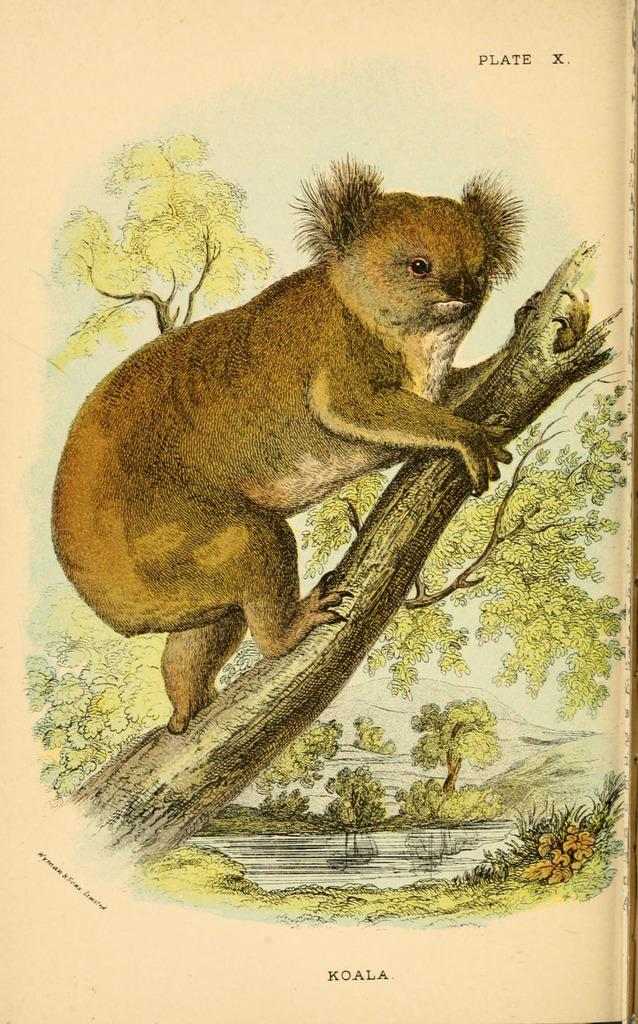What is the main subject of the image? The image contains an art piece. What animal is depicted in the art piece? The art piece depicts a koala. What color is the background of the art piece? The background of the art piece is in cream color. How many cherries are hanging from the koala's paws in the image? There are no cherries present in the image, and the koala is not depicted as holding any cherries. 